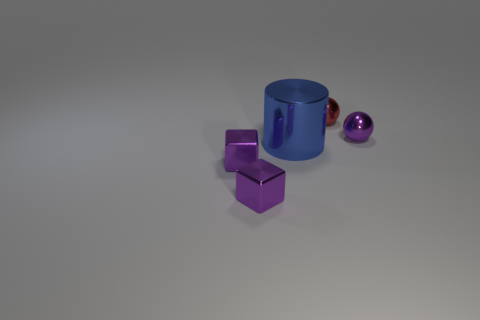Add 2 big metallic cylinders. How many objects exist? 7 Subtract all cubes. How many objects are left? 3 Subtract all small purple metal spheres. Subtract all tiny brown things. How many objects are left? 4 Add 3 blue metallic objects. How many blue metallic objects are left? 4 Add 3 red spheres. How many red spheres exist? 4 Subtract 2 purple blocks. How many objects are left? 3 